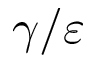Convert formula to latex. <formula><loc_0><loc_0><loc_500><loc_500>\gamma / \varepsilon</formula> 